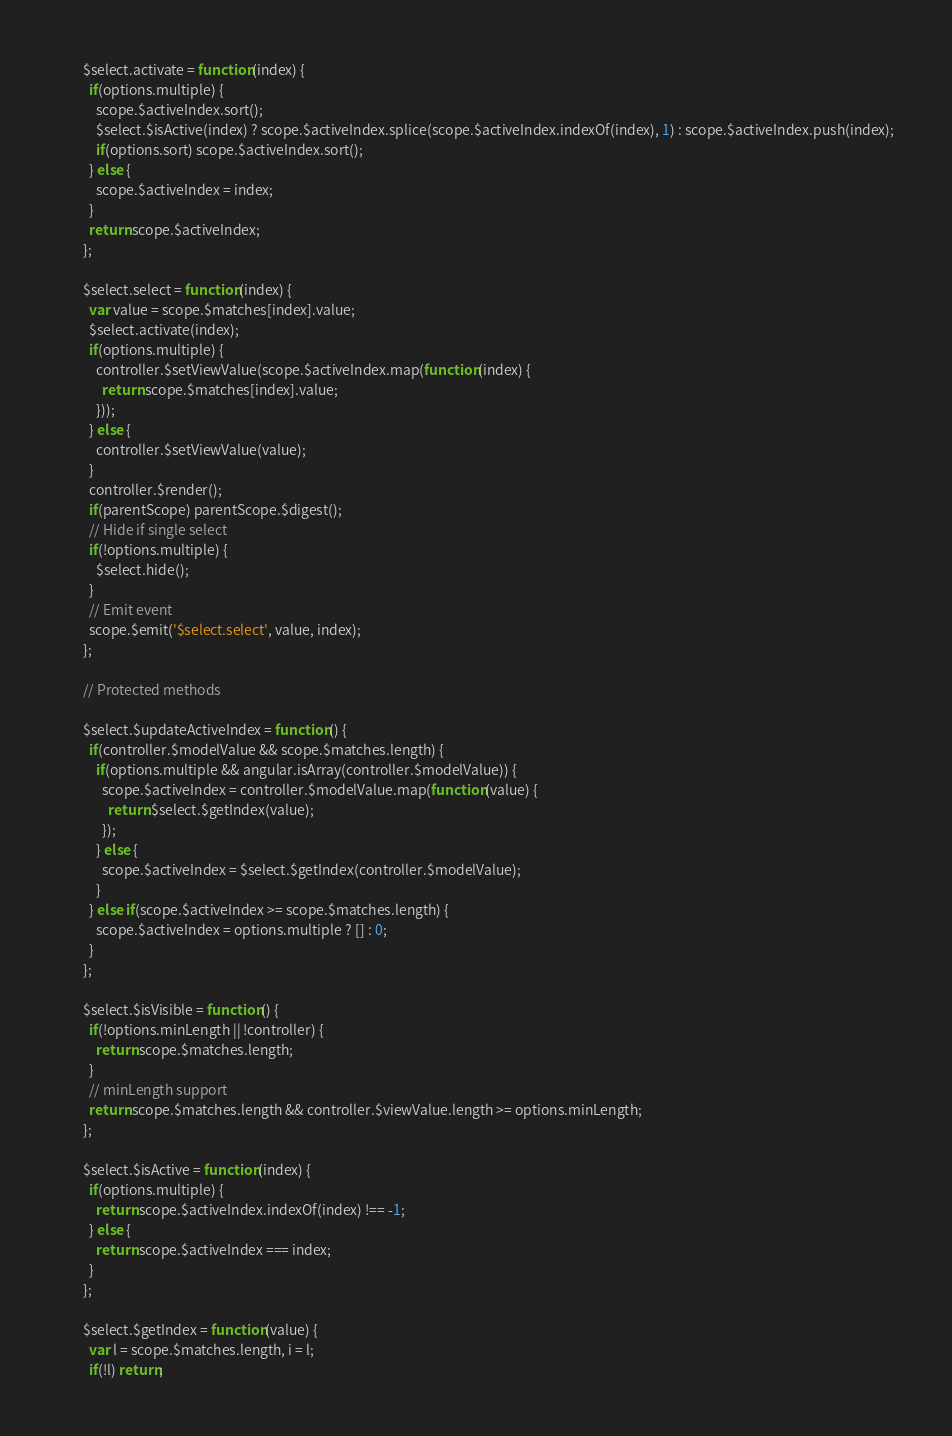<code> <loc_0><loc_0><loc_500><loc_500><_JavaScript_>        $select.activate = function(index) {
          if(options.multiple) {
            scope.$activeIndex.sort();
            $select.$isActive(index) ? scope.$activeIndex.splice(scope.$activeIndex.indexOf(index), 1) : scope.$activeIndex.push(index);
            if(options.sort) scope.$activeIndex.sort();
          } else {
            scope.$activeIndex = index;
          }
          return scope.$activeIndex;
        };

        $select.select = function(index) {
          var value = scope.$matches[index].value;
          $select.activate(index);
          if(options.multiple) {
            controller.$setViewValue(scope.$activeIndex.map(function(index) {
              return scope.$matches[index].value;
            }));
          } else {
            controller.$setViewValue(value);
          }
          controller.$render();
          if(parentScope) parentScope.$digest();
          // Hide if single select
          if(!options.multiple) {
            $select.hide();
          }
          // Emit event
          scope.$emit('$select.select', value, index);
        };

        // Protected methods

        $select.$updateActiveIndex = function() {
          if(controller.$modelValue && scope.$matches.length) {
            if(options.multiple && angular.isArray(controller.$modelValue)) {
              scope.$activeIndex = controller.$modelValue.map(function(value) {
                return $select.$getIndex(value);
              });
            } else {
              scope.$activeIndex = $select.$getIndex(controller.$modelValue);
            }
          } else if(scope.$activeIndex >= scope.$matches.length) {
            scope.$activeIndex = options.multiple ? [] : 0;
          }
        };

        $select.$isVisible = function() {
          if(!options.minLength || !controller) {
            return scope.$matches.length;
          }
          // minLength support
          return scope.$matches.length && controller.$viewValue.length >= options.minLength;
        };

        $select.$isActive = function(index) {
          if(options.multiple) {
            return scope.$activeIndex.indexOf(index) !== -1;
          } else {
            return scope.$activeIndex === index;
          }
        };

        $select.$getIndex = function(value) {
          var l = scope.$matches.length, i = l;
          if(!l) return;</code> 